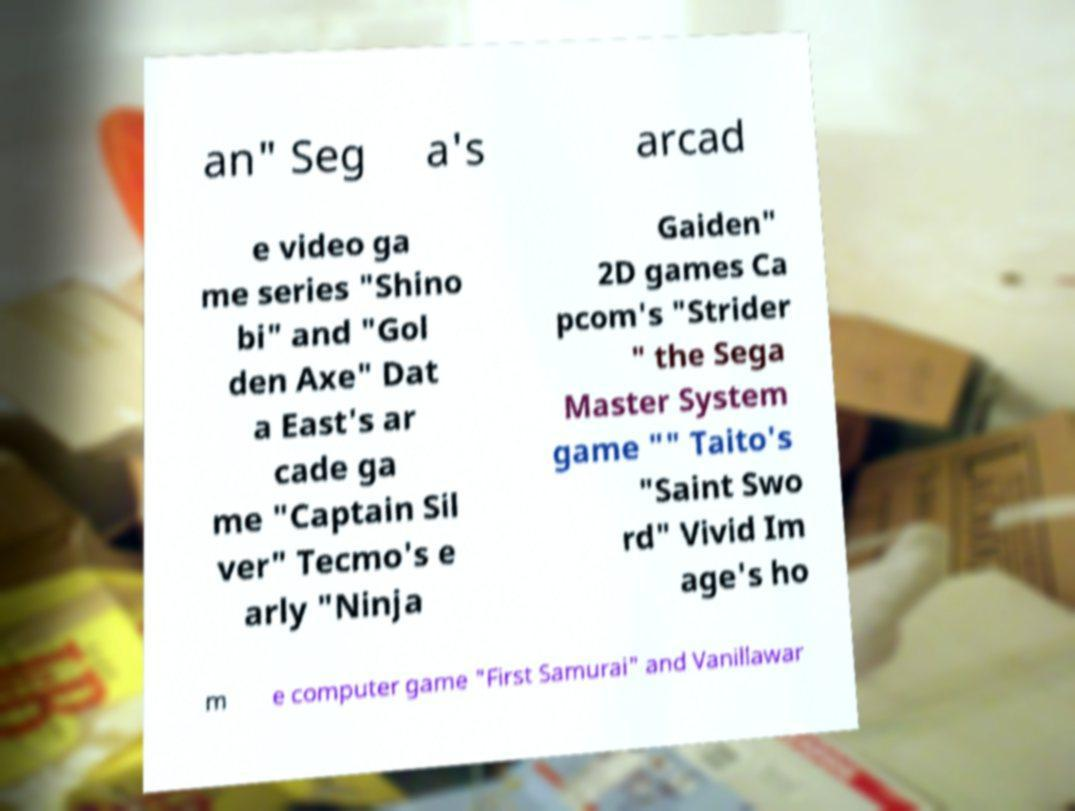I need the written content from this picture converted into text. Can you do that? an" Seg a's arcad e video ga me series "Shino bi" and "Gol den Axe" Dat a East's ar cade ga me "Captain Sil ver" Tecmo's e arly "Ninja Gaiden" 2D games Ca pcom's "Strider " the Sega Master System game "" Taito's "Saint Swo rd" Vivid Im age's ho m e computer game "First Samurai" and Vanillawar 